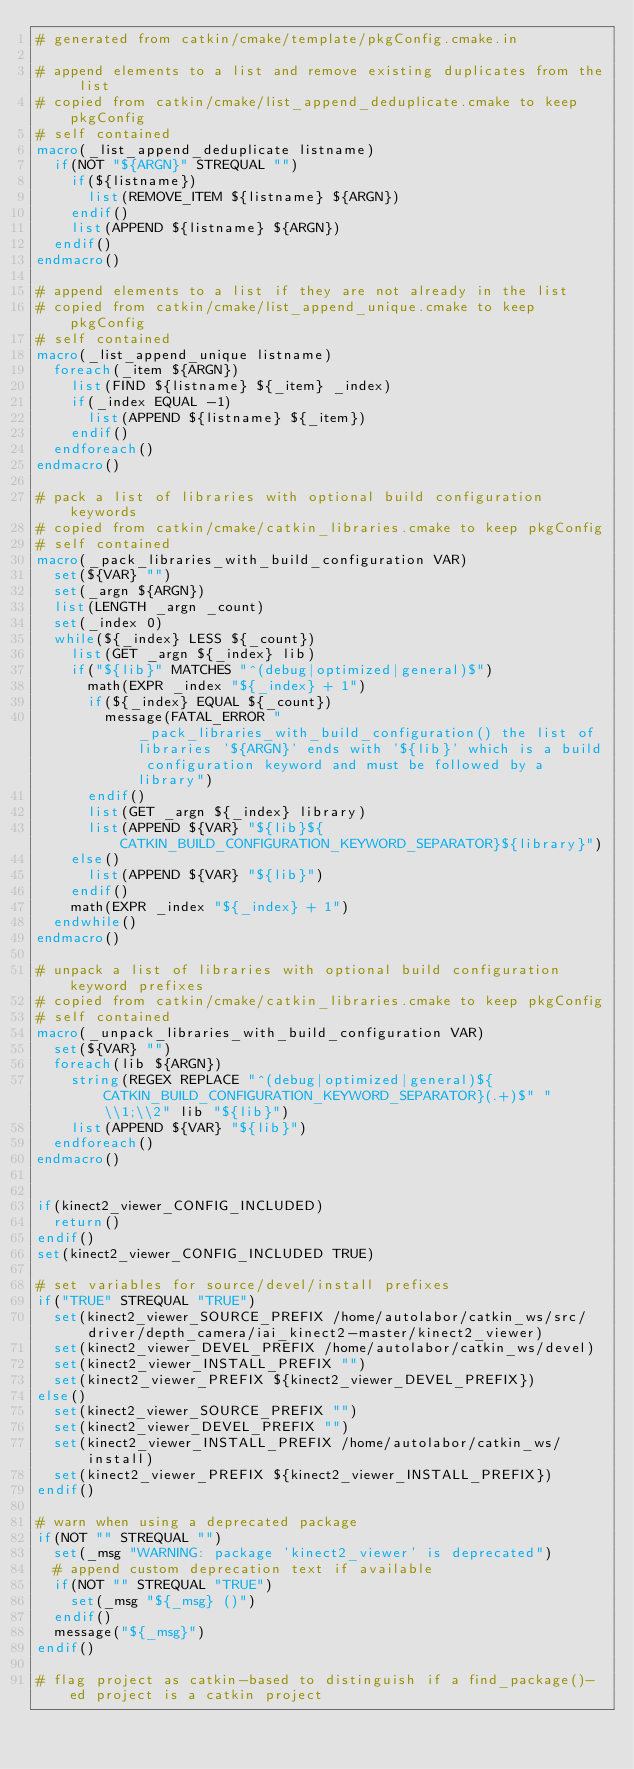Convert code to text. <code><loc_0><loc_0><loc_500><loc_500><_CMake_># generated from catkin/cmake/template/pkgConfig.cmake.in

# append elements to a list and remove existing duplicates from the list
# copied from catkin/cmake/list_append_deduplicate.cmake to keep pkgConfig
# self contained
macro(_list_append_deduplicate listname)
  if(NOT "${ARGN}" STREQUAL "")
    if(${listname})
      list(REMOVE_ITEM ${listname} ${ARGN})
    endif()
    list(APPEND ${listname} ${ARGN})
  endif()
endmacro()

# append elements to a list if they are not already in the list
# copied from catkin/cmake/list_append_unique.cmake to keep pkgConfig
# self contained
macro(_list_append_unique listname)
  foreach(_item ${ARGN})
    list(FIND ${listname} ${_item} _index)
    if(_index EQUAL -1)
      list(APPEND ${listname} ${_item})
    endif()
  endforeach()
endmacro()

# pack a list of libraries with optional build configuration keywords
# copied from catkin/cmake/catkin_libraries.cmake to keep pkgConfig
# self contained
macro(_pack_libraries_with_build_configuration VAR)
  set(${VAR} "")
  set(_argn ${ARGN})
  list(LENGTH _argn _count)
  set(_index 0)
  while(${_index} LESS ${_count})
    list(GET _argn ${_index} lib)
    if("${lib}" MATCHES "^(debug|optimized|general)$")
      math(EXPR _index "${_index} + 1")
      if(${_index} EQUAL ${_count})
        message(FATAL_ERROR "_pack_libraries_with_build_configuration() the list of libraries '${ARGN}' ends with '${lib}' which is a build configuration keyword and must be followed by a library")
      endif()
      list(GET _argn ${_index} library)
      list(APPEND ${VAR} "${lib}${CATKIN_BUILD_CONFIGURATION_KEYWORD_SEPARATOR}${library}")
    else()
      list(APPEND ${VAR} "${lib}")
    endif()
    math(EXPR _index "${_index} + 1")
  endwhile()
endmacro()

# unpack a list of libraries with optional build configuration keyword prefixes
# copied from catkin/cmake/catkin_libraries.cmake to keep pkgConfig
# self contained
macro(_unpack_libraries_with_build_configuration VAR)
  set(${VAR} "")
  foreach(lib ${ARGN})
    string(REGEX REPLACE "^(debug|optimized|general)${CATKIN_BUILD_CONFIGURATION_KEYWORD_SEPARATOR}(.+)$" "\\1;\\2" lib "${lib}")
    list(APPEND ${VAR} "${lib}")
  endforeach()
endmacro()


if(kinect2_viewer_CONFIG_INCLUDED)
  return()
endif()
set(kinect2_viewer_CONFIG_INCLUDED TRUE)

# set variables for source/devel/install prefixes
if("TRUE" STREQUAL "TRUE")
  set(kinect2_viewer_SOURCE_PREFIX /home/autolabor/catkin_ws/src/driver/depth_camera/iai_kinect2-master/kinect2_viewer)
  set(kinect2_viewer_DEVEL_PREFIX /home/autolabor/catkin_ws/devel)
  set(kinect2_viewer_INSTALL_PREFIX "")
  set(kinect2_viewer_PREFIX ${kinect2_viewer_DEVEL_PREFIX})
else()
  set(kinect2_viewer_SOURCE_PREFIX "")
  set(kinect2_viewer_DEVEL_PREFIX "")
  set(kinect2_viewer_INSTALL_PREFIX /home/autolabor/catkin_ws/install)
  set(kinect2_viewer_PREFIX ${kinect2_viewer_INSTALL_PREFIX})
endif()

# warn when using a deprecated package
if(NOT "" STREQUAL "")
  set(_msg "WARNING: package 'kinect2_viewer' is deprecated")
  # append custom deprecation text if available
  if(NOT "" STREQUAL "TRUE")
    set(_msg "${_msg} ()")
  endif()
  message("${_msg}")
endif()

# flag project as catkin-based to distinguish if a find_package()-ed project is a catkin project</code> 